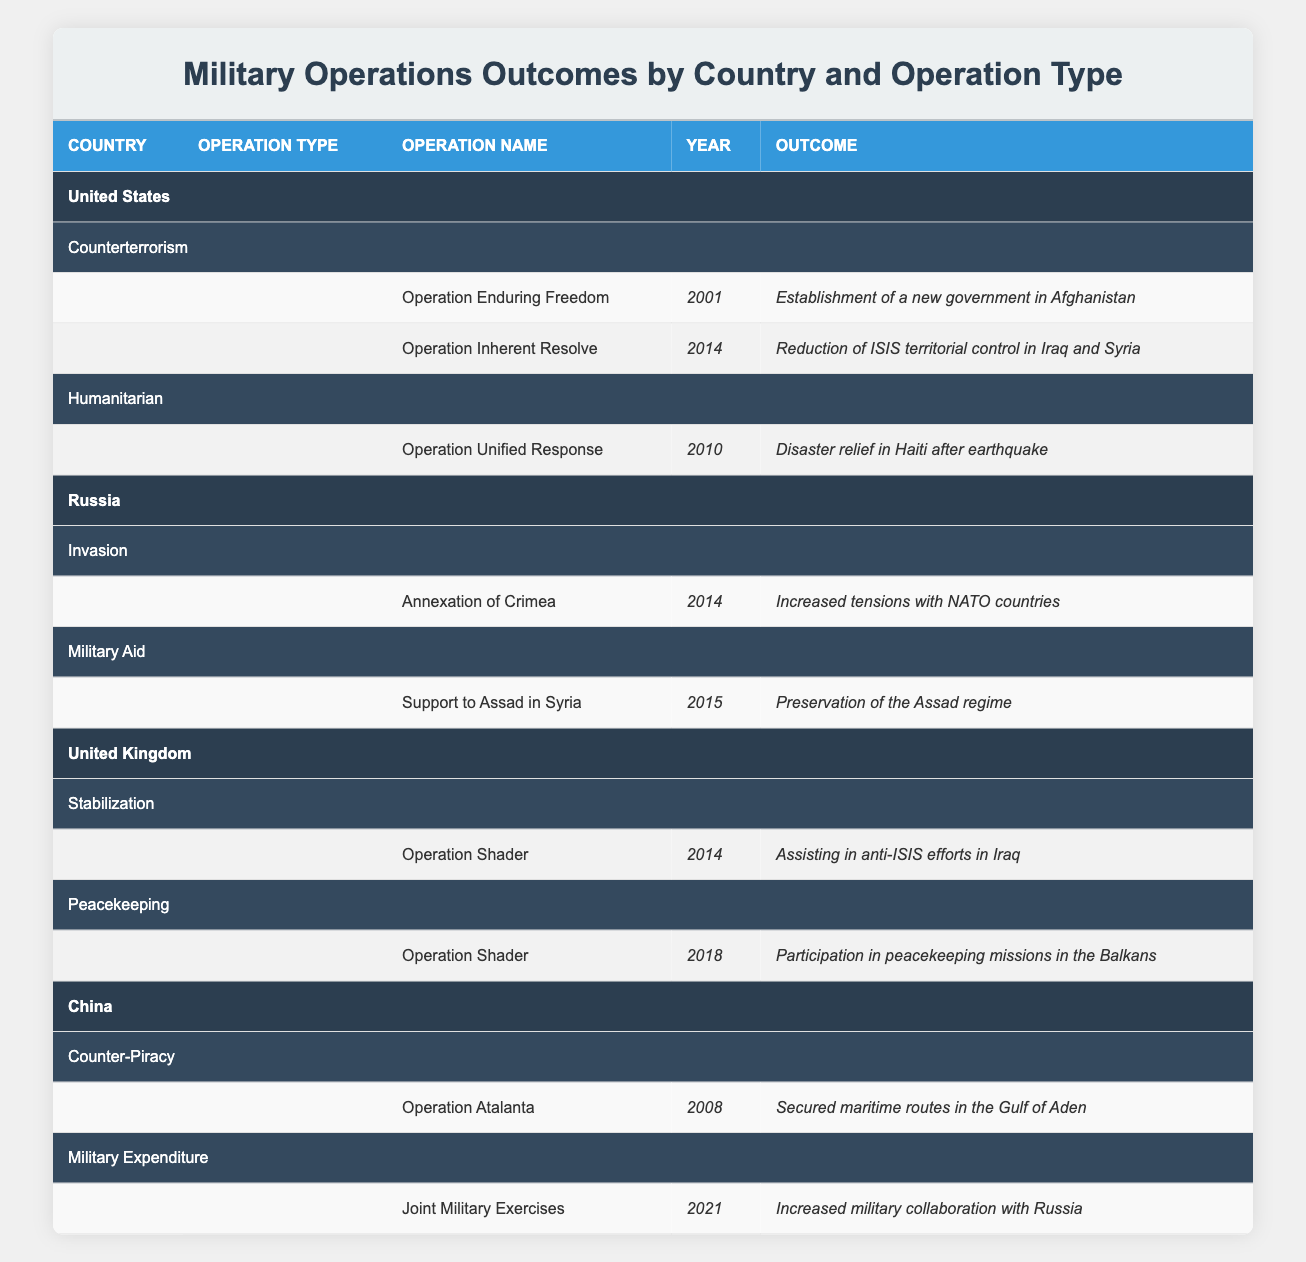What military operation by the United States aimed at counterterrorism was conducted in 2001? The table shows that the operation conducted by the United States aimed at counterterrorism in 2001 is "Operation Enduring Freedom".
Answer: Operation Enduring Freedom What was the outcome of the United Kingdom's Operation Shader in 2014? According to the table, the outcome of the United Kingdom's Operation Shader in 2014 was assisting in anti-ISIS efforts in Iraq.
Answer: Assisting in anti-ISIS efforts in Iraq Did China conduct any military operations that focused on counter-piracy? The table indicates that China did conduct military operations focused on counter-piracy, specifically "Operation Atalanta" in 2008.
Answer: Yes What is the most recent military operation listed in the table, and what is its outcome? By reviewing the table, the most recent military operation is "Joint Military Exercises" by China in 2021, which resulted in increased military collaboration with Russia.
Answer: Joint Military Exercises; Increased military collaboration with Russia Which country's military operation resulted in "Increased tensions with NATO countries"? The table indicates that the operation resulting in "Increased tensions with NATO countries" is the "Annexation of Crimea" conducted by Russia in 2014.
Answer: Russia How many different operation types were conducted by the United States, and what are they? The table lists two operation types conducted by the United States: Counterterrorism and Humanitarian. Therefore, there are two distinct types.
Answer: Two: Counterterrorism, Humanitarian What was the outcome of China's military aid operation in 2015? The operation listed under military aid by China in 2015 is "Support to Assad in Syria", which resulted in the preservation of the Assad regime.
Answer: Preservation of the Assad regime Was there any military operation by the United Kingdom in 2018 that participated in peacekeeping missions? The table confirms that the United Kingdom did conduct a military operation in 2018, "Operation Shader", which was involved in peacekeeping missions in the Balkans.
Answer: Yes What is the difference in years between the first and last operations listed for Russia? The first operation listed for Russia is in 2014 ("Annexation of Crimea"), and the last is also in 2015 ("Support to Assad in Syria"). The difference in years is 1 year (2015 - 2014 = 1).
Answer: 1 year 